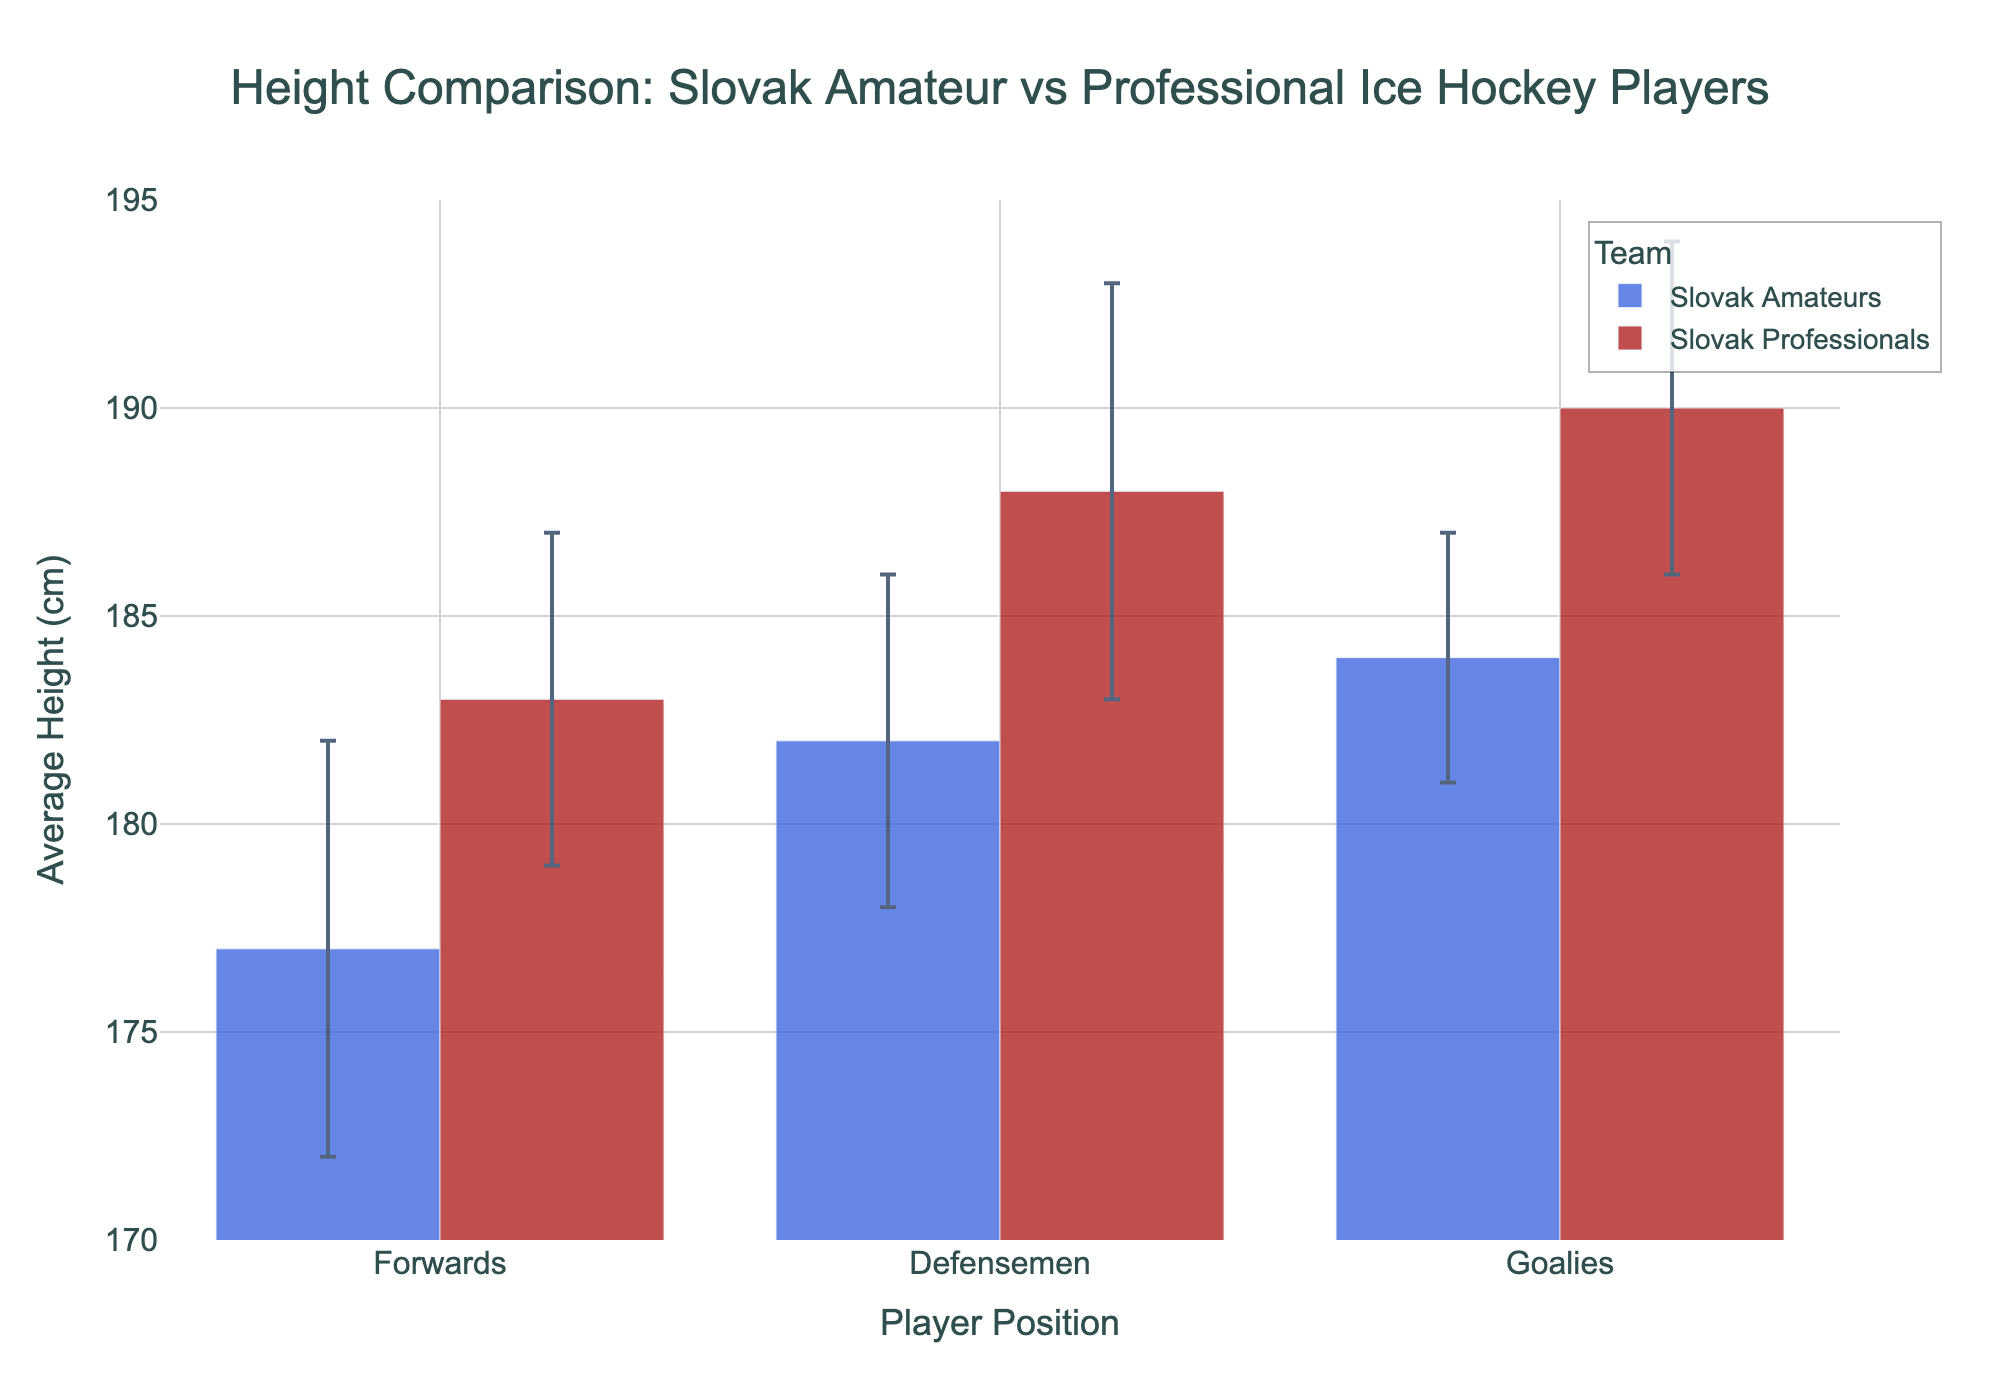What's the title of the figure? The title is clearly written at the top of the figure.
Answer: Height Comparison: Slovak Amateur vs Professional Ice Hockey Players What is the range of the y-axis? The y-axis range is shown on the left side and goes from 170 to 195.
Answer: 170 to 195 Which player type has the highest average height among Slovak Professionals? By comparing the heights of the three player types for Slovak Professionals, Goalies have the highest average height.
Answer: Goalies What is the difference in average height between Amateur and Professional Forwards? The average height for Amateur Forwards is 177 cm, and for Professional Forwards, it is 183 cm. The difference is 183 - 177 = 6 cm.
Answer: 6 cm Which group has the smallest standard deviation in average height? The standard deviations are given as error bars. For Slovak Amateurs, Forwards have an SD of 5, Defensemen 4, and Goalies 3. For Slovak Professionals, Forwards have an SD of 4, Defensemen 5, and Goalies 4. The smallest SD is for Slovak Amateur Goalies.
Answer: Slovak Amateur Goalies Which player type is taller on average, Amateur Defensemen or Professional Forwards? The average height of Amateur Defensemen is 182 cm, while Professional Forwards have an average height of 183 cm. Therefore, Professional Forwards are taller.
Answer: Professional Forwards What does the error bar represent in the figure? The error bars represent the standard deviation of the average height for each player type and team, indicating variability.
Answer: Standard deviation Which team's Defensemen are taller on average? Comparing the average heights of Defensemen, Slovak Professional Defensemen are taller at 188 cm compared to Slovak Amateur Defensemen at 182 cm.
Answer: Slovak Professionals What is the average height range for Professional Goalies considering the standard deviation? The average height is 190 cm with a standard deviation of 4. The range is 190 ± 4, or 186 to 194 cm.
Answer: 186 to 194 cm How much taller are Professional Goalies on average compared to Amateur Goalies? The average height for Professional Goalies is 190 cm, and for Amateur Goalies, it is 184 cm. The difference is 190 - 184 = 6 cm.
Answer: 6 cm 